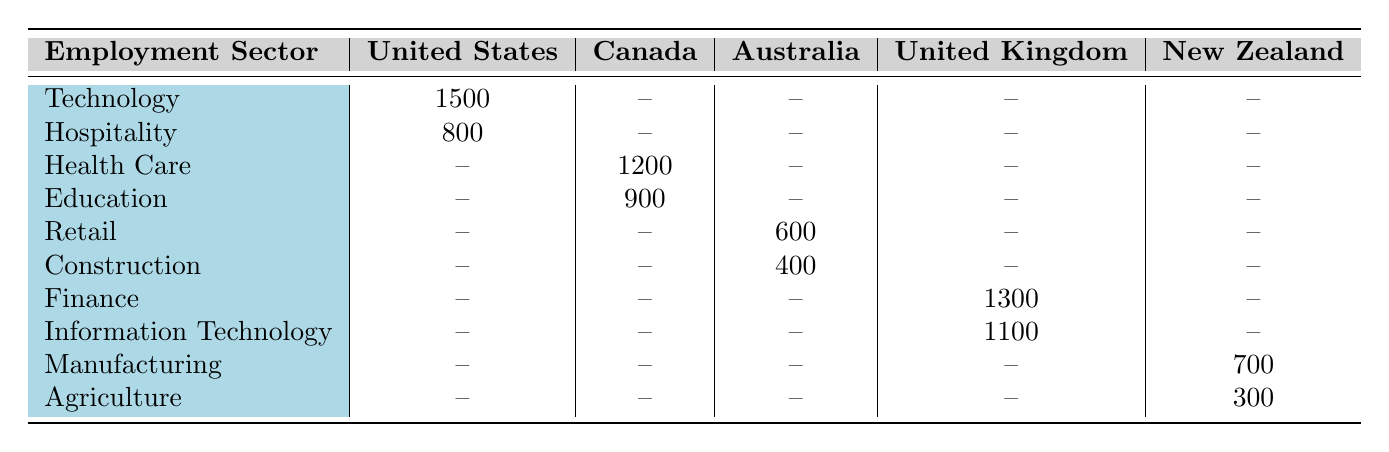What is the number of Chinese immigrants in the Technology sector in the United States? The table lists the number of immigrants in the Technology sector specifically for the United States as 1500.
Answer: 1500 Which country has the highest number of immigrants in the Health Care sector? In the table, the only country listed under the Health Care sector is Canada, with 1200 immigrants. Therefore, Canada has the highest number.
Answer: Canada How many total Chinese immigrants are employed in the Hospitality and Education sectors combined in the United States and Canada? From the United States, there are 800 in Hospitality, and from Canada, there are 900 in Education. Adding these numbers gives 800 + 900 = 1700.
Answer: 1700 Is there any sector in Australia that has more than 500 Chinese immigrants? The Retail sector in Australia has 600 immigrants, which is greater than 500, while Construction has 400, which does not. Therefore, yes, there is one sector that has more than 500.
Answer: Yes What is the total number of Chinese immigrants in the Manufacturing and Agriculture sectors in New Zealand? The table shows 700 immigrants in the Manufacturing sector and 300 in Agriculture. Adding these gives 700 + 300 = 1000.
Answer: 1000 Which country has more Chinese immigrants in the Finance sector, the United Kingdom or the United States? The table shows that the United Kingdom has 1300 immigrants in Finance, while the United States does not have any in this sector. Thus, the United Kingdom has more.
Answer: United Kingdom How many more immigrants are there in the Information Technology sector in the United Kingdom compared to the number in the Agriculture sector in New Zealand? The United Kingdom has 1100 immigrants in Information Technology and New Zealand has 300 in Agriculture. The difference is calculated as 1100 - 300 = 800.
Answer: 800 Are there any employment sectors in the United States with fewer than 1000 Chinese immigrants? The Hospitality sector has 800 immigrants, which is fewer than 1000, while Technology has 1500, which does not. Thus, yes, there is at least one sector with fewer than 1000.
Answer: Yes What is the average number of Chinese immigrants across all sectors listed for Canada? In Canada, the Health Care sector has 1200 immigrants and Education has 900. To find the average, sum these values (1200 + 900 = 2100) and divide by 2 (2100 / 2 = 1050).
Answer: 1050 